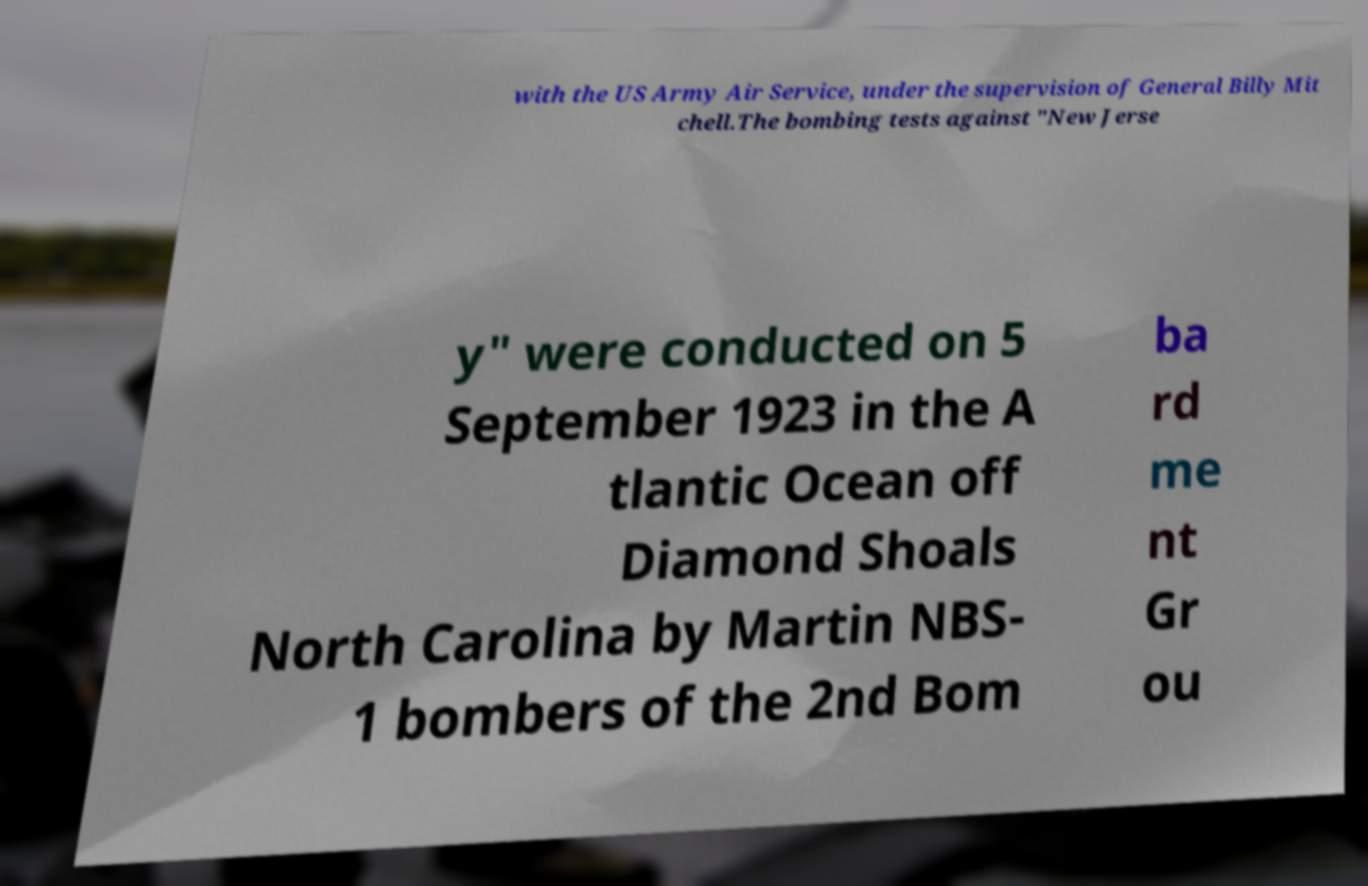Please identify and transcribe the text found in this image. with the US Army Air Service, under the supervision of General Billy Mit chell.The bombing tests against "New Jerse y" were conducted on 5 September 1923 in the A tlantic Ocean off Diamond Shoals North Carolina by Martin NBS- 1 bombers of the 2nd Bom ba rd me nt Gr ou 